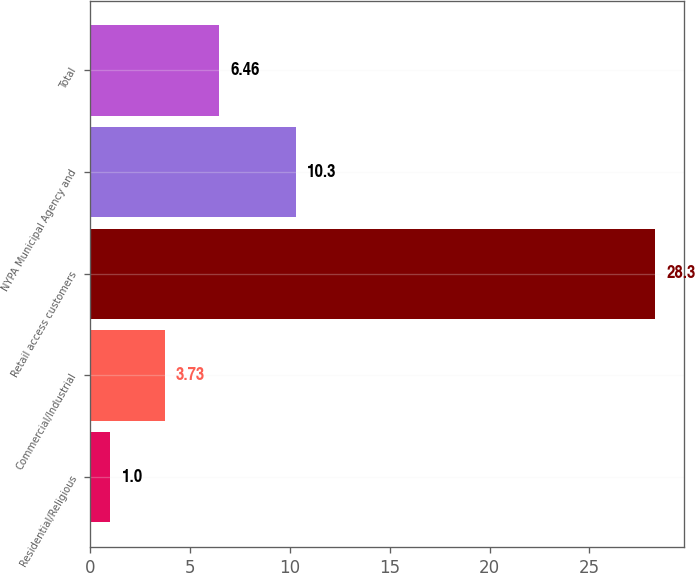Convert chart. <chart><loc_0><loc_0><loc_500><loc_500><bar_chart><fcel>Residential/Religious<fcel>Commercial/Industrial<fcel>Retail access customers<fcel>NYPA Municipal Agency and<fcel>Total<nl><fcel>1<fcel>3.73<fcel>28.3<fcel>10.3<fcel>6.46<nl></chart> 